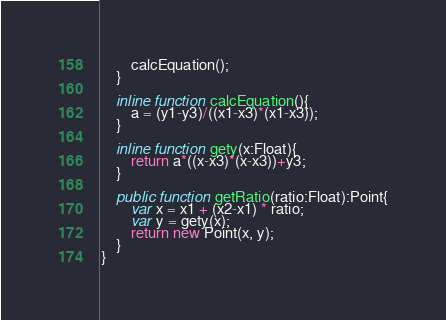Convert code to text. <code><loc_0><loc_0><loc_500><loc_500><_Haxe_>        calcEquation();
    }

    inline function calcEquation(){
        a = (y1-y3)/((x1-x3)*(x1-x3));
    }

    inline function gety(x:Float){
        return a*((x-x3)*(x-x3))+y3;
    }

    public function getRatio(ratio:Float):Point{
        var x = x1 + (x2-x1) * ratio;
        var y = gety(x);
        return new Point(x, y);
    }
}</code> 